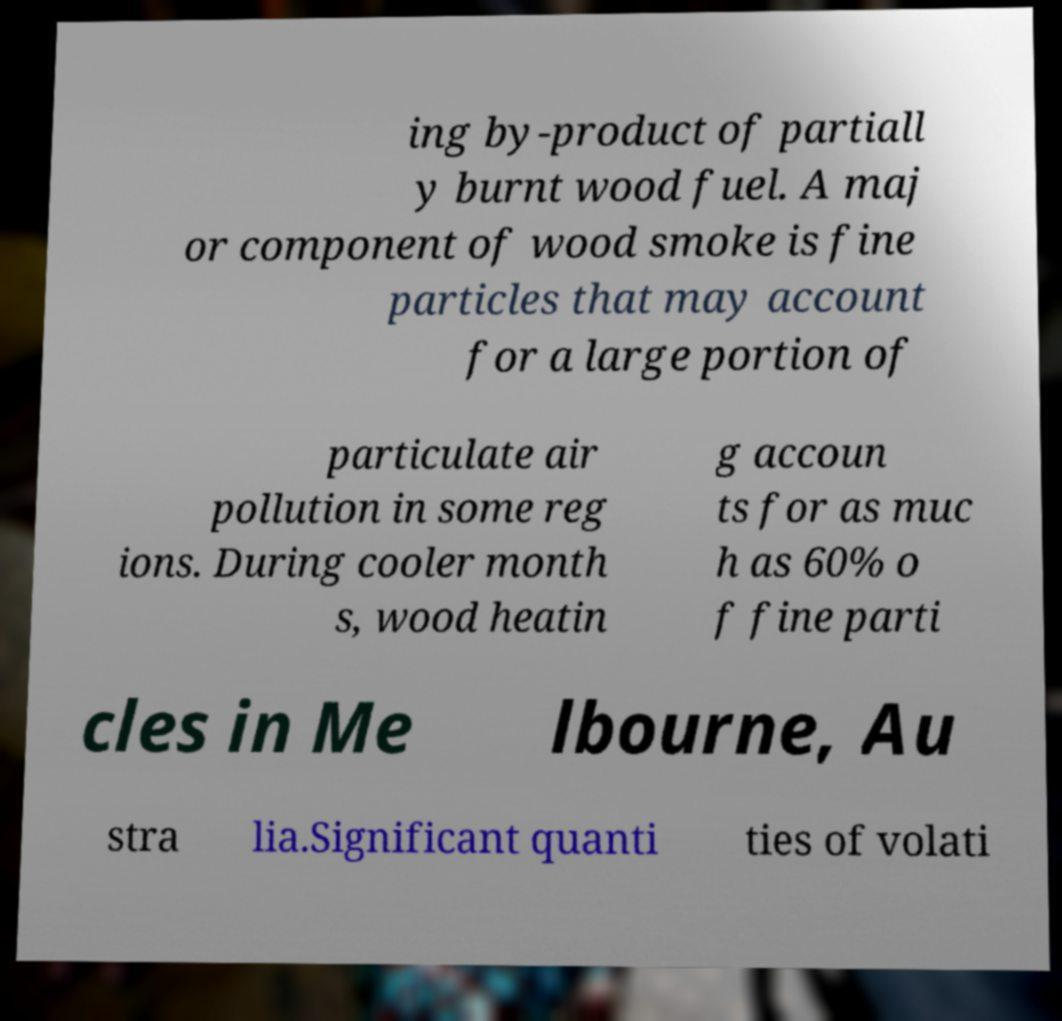For documentation purposes, I need the text within this image transcribed. Could you provide that? ing by-product of partiall y burnt wood fuel. A maj or component of wood smoke is fine particles that may account for a large portion of particulate air pollution in some reg ions. During cooler month s, wood heatin g accoun ts for as muc h as 60% o f fine parti cles in Me lbourne, Au stra lia.Significant quanti ties of volati 